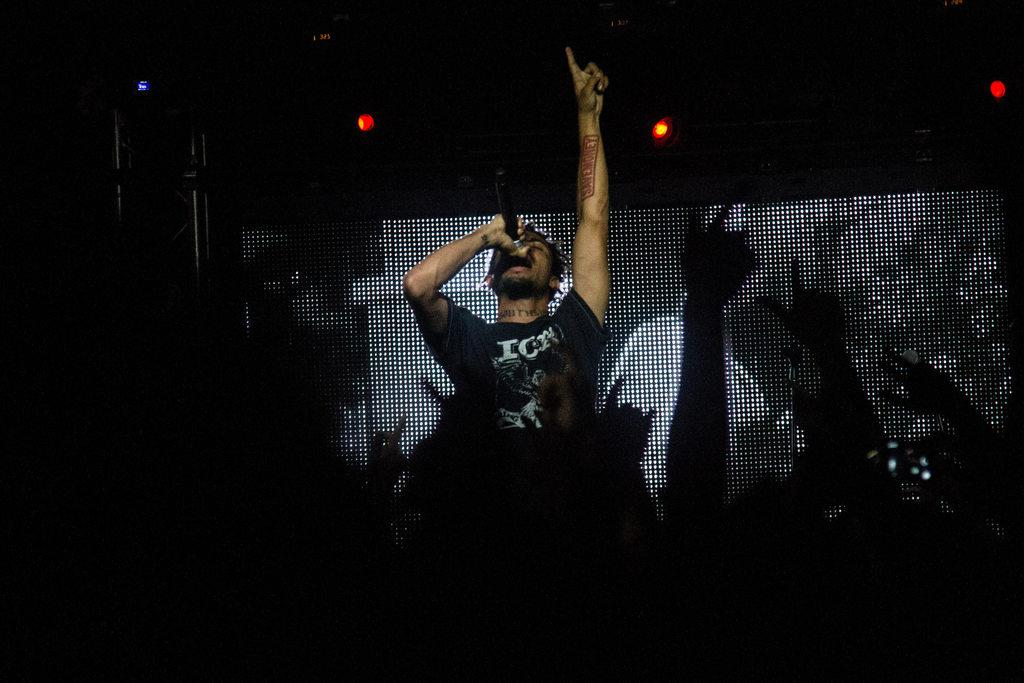What is the man in the image doing? The man is singing in the image. What type of event is taking place in the image? The scene appears to be a concert. What can be seen in the background of the image? There is a screen in the background of the image. What is located on the left side of the image? There is a stand on the left side of the image. What color are the lights visible at the top of the image? The lights in the image are red. How many lines can be seen on the man's toe in the image? There are no visible toes or lines on the man's toes in the image. 